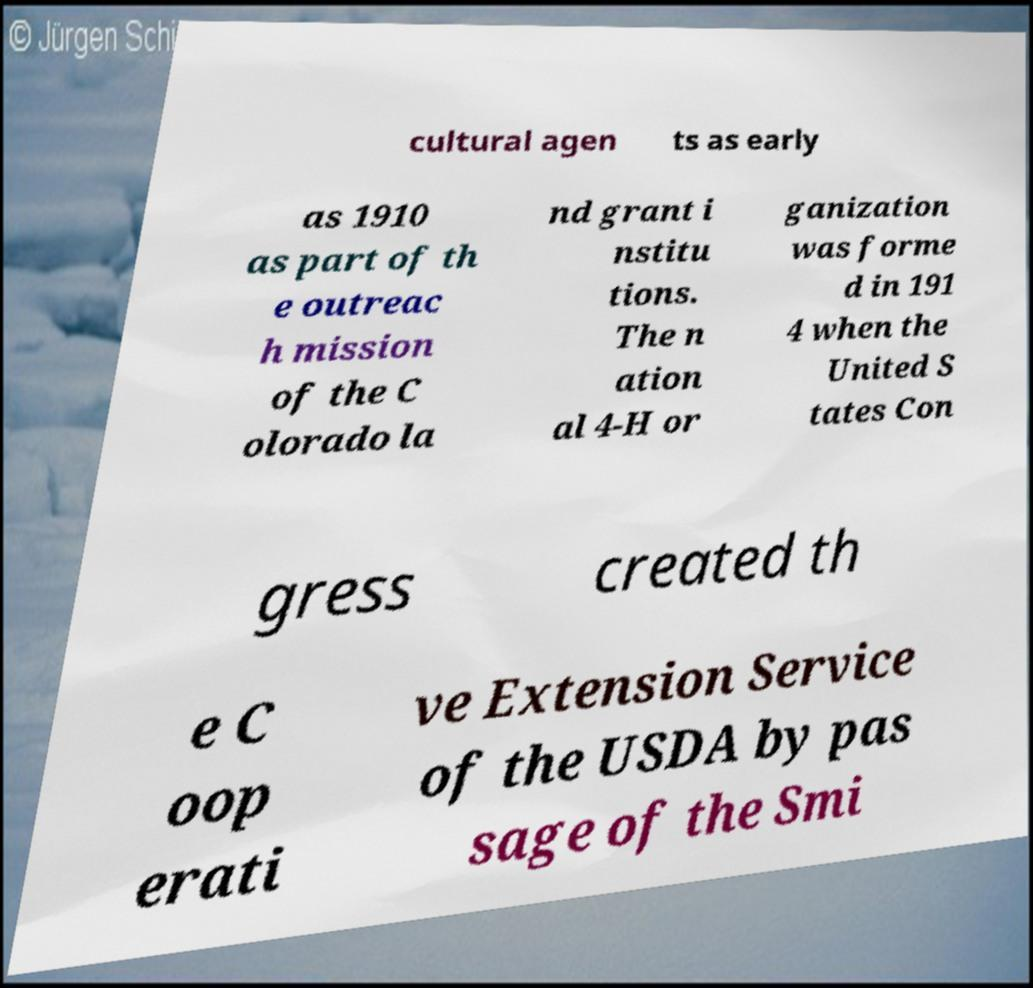What messages or text are displayed in this image? I need them in a readable, typed format. cultural agen ts as early as 1910 as part of th e outreac h mission of the C olorado la nd grant i nstitu tions. The n ation al 4-H or ganization was forme d in 191 4 when the United S tates Con gress created th e C oop erati ve Extension Service of the USDA by pas sage of the Smi 